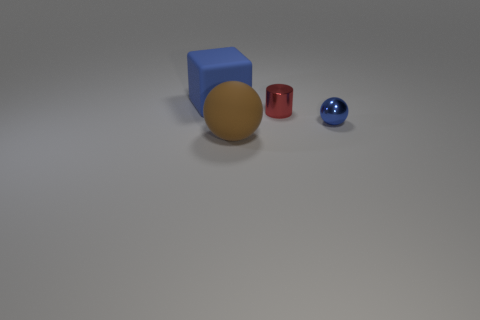Can you tell the size relationship between the blue cube and the gold sphere? The blue cube is larger compared to the gold sphere, taking up more space visually. Both objects display characteristics of geometric solids with defined boundaries. 